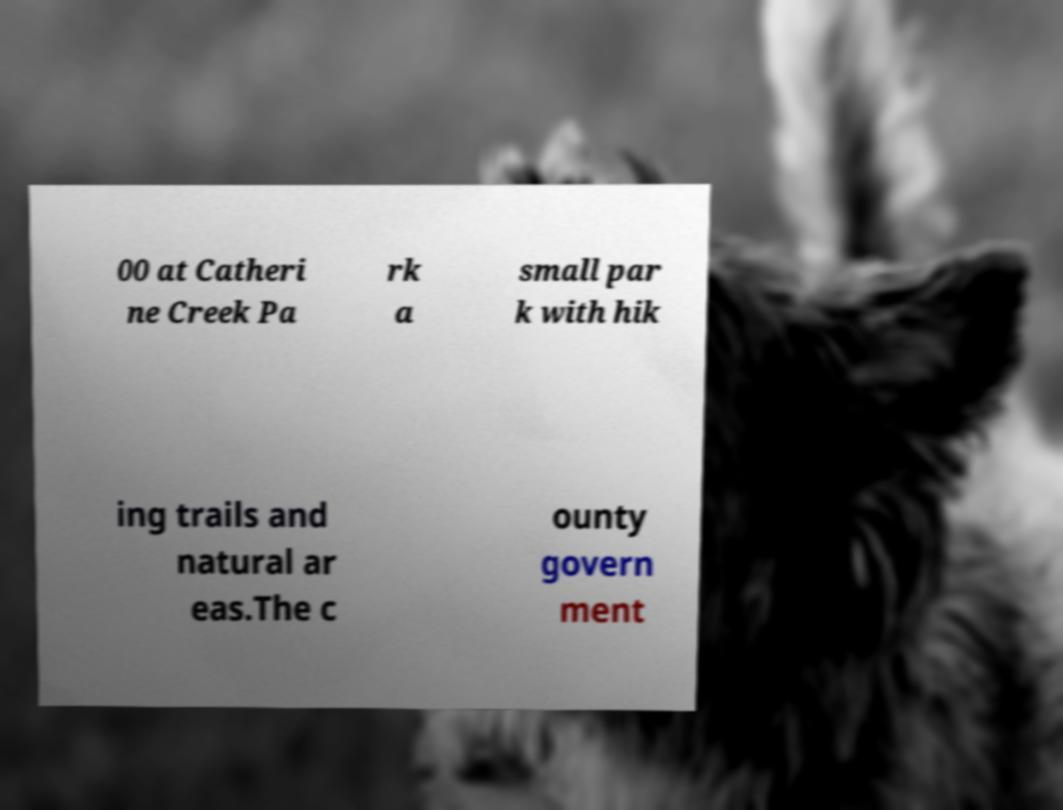Could you extract and type out the text from this image? 00 at Catheri ne Creek Pa rk a small par k with hik ing trails and natural ar eas.The c ounty govern ment 